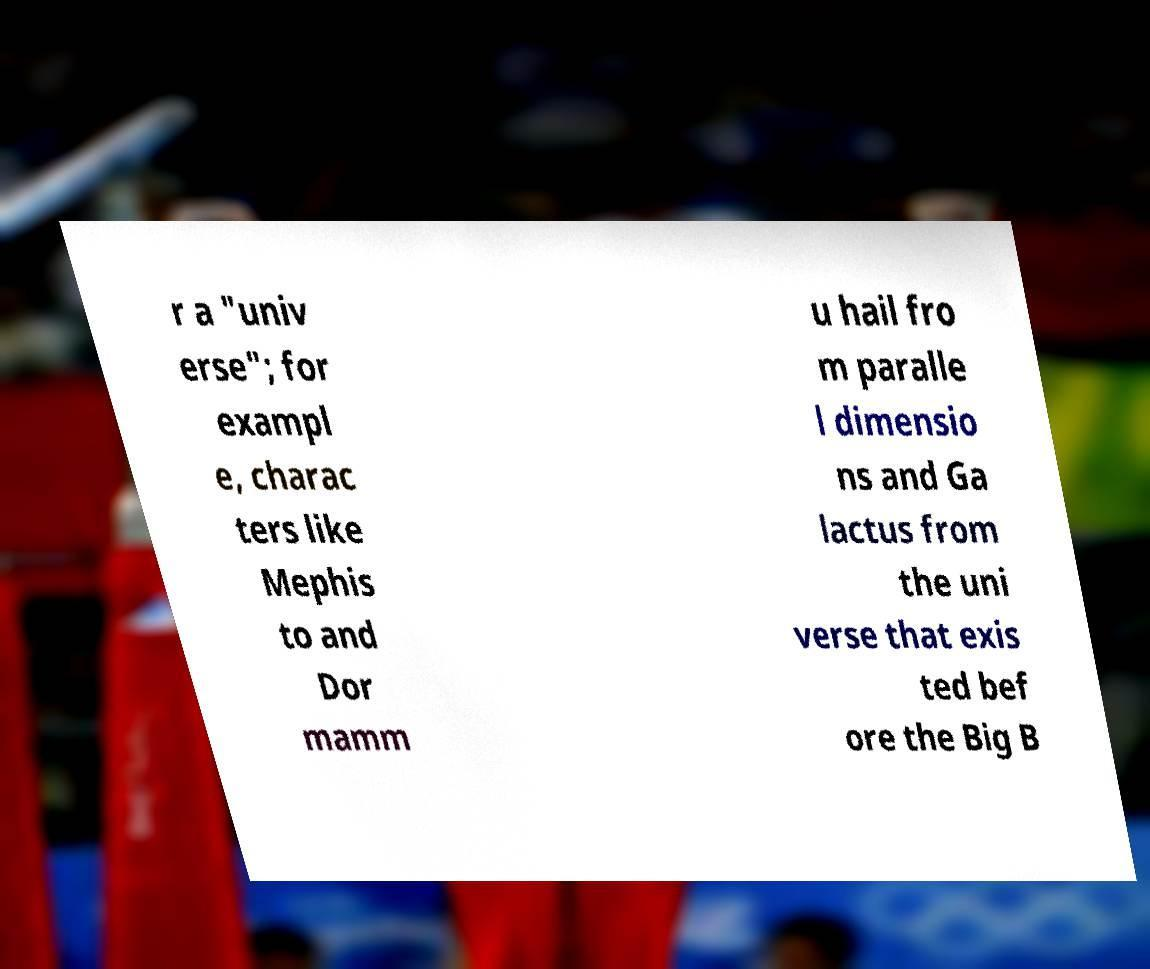I need the written content from this picture converted into text. Can you do that? r a "univ erse"; for exampl e, charac ters like Mephis to and Dor mamm u hail fro m paralle l dimensio ns and Ga lactus from the uni verse that exis ted bef ore the Big B 